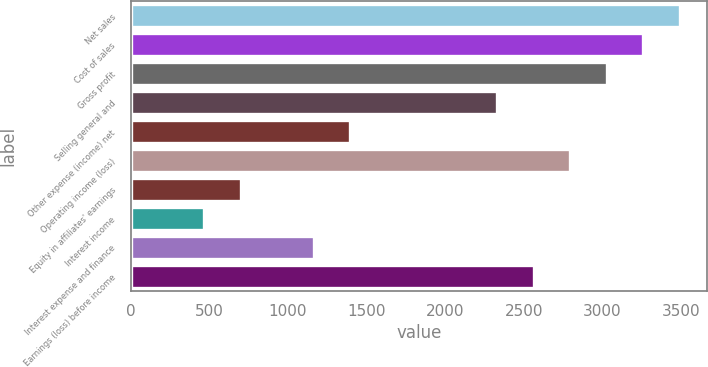<chart> <loc_0><loc_0><loc_500><loc_500><bar_chart><fcel>Net sales<fcel>Cost of sales<fcel>Gross profit<fcel>Selling general and<fcel>Other expense (income) net<fcel>Operating income (loss)<fcel>Equity in affiliates' earnings<fcel>Interest income<fcel>Interest expense and finance<fcel>Earnings (loss) before income<nl><fcel>3493.36<fcel>3260.52<fcel>3027.68<fcel>2329.16<fcel>1397.8<fcel>2794.84<fcel>699.28<fcel>466.44<fcel>1164.96<fcel>2562<nl></chart> 